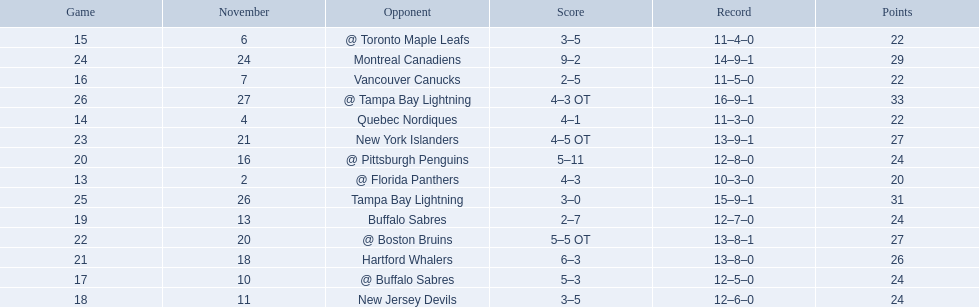What were the scores? @ Florida Panthers, 4–3, Quebec Nordiques, 4–1, @ Toronto Maple Leafs, 3–5, Vancouver Canucks, 2–5, @ Buffalo Sabres, 5–3, New Jersey Devils, 3–5, Buffalo Sabres, 2–7, @ Pittsburgh Penguins, 5–11, Hartford Whalers, 6–3, @ Boston Bruins, 5–5 OT, New York Islanders, 4–5 OT, Montreal Canadiens, 9–2, Tampa Bay Lightning, 3–0, @ Tampa Bay Lightning, 4–3 OT. What score was the closest? New York Islanders, 4–5 OT. What team had that score? New York Islanders. 